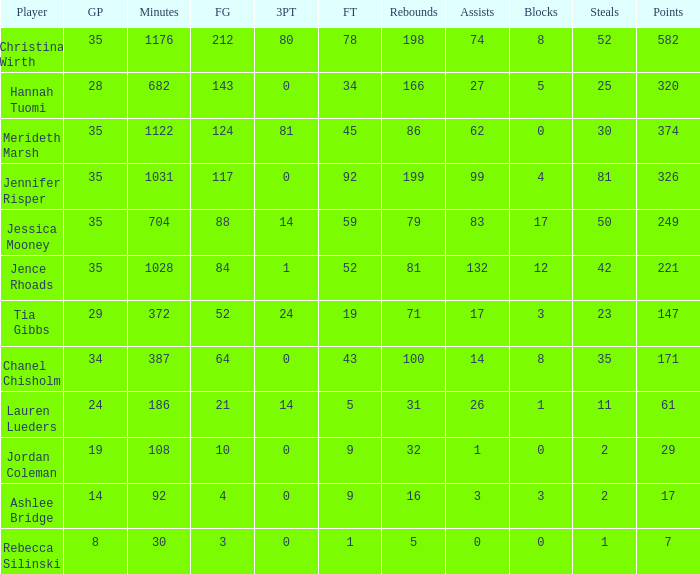What was the number of blockings in the game that had 198 rebounds? 8.0. 